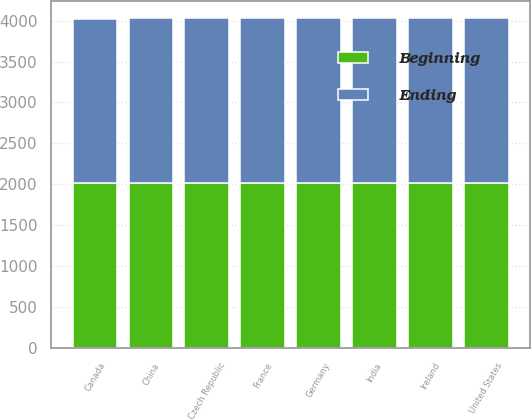Convert chart to OTSL. <chart><loc_0><loc_0><loc_500><loc_500><stacked_bar_chart><ecel><fcel>United States<fcel>Canada<fcel>China<fcel>Czech Republic<fcel>France<fcel>Germany<fcel>India<fcel>Ireland<nl><fcel>Ending<fcel>2014<fcel>2005<fcel>2012<fcel>2014<fcel>2015<fcel>2011<fcel>2017<fcel>2013<nl><fcel>Beginning<fcel>2017<fcel>2017<fcel>2017<fcel>2017<fcel>2017<fcel>2017<fcel>2017<fcel>2017<nl></chart> 